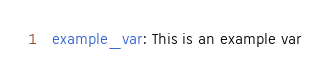Convert code to text. <code><loc_0><loc_0><loc_500><loc_500><_YAML_>  example_var: This is an example var

</code> 